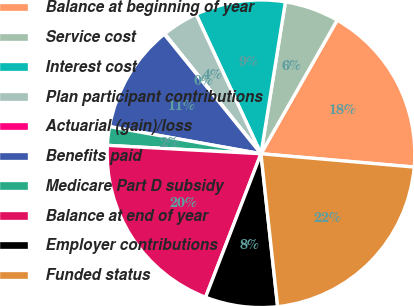<chart> <loc_0><loc_0><loc_500><loc_500><pie_chart><fcel>Balance at beginning of year<fcel>Service cost<fcel>Interest cost<fcel>Plan participant contributions<fcel>Actuarial (gain)/loss<fcel>Benefits paid<fcel>Medicare Part D subsidy<fcel>Balance at end of year<fcel>Employer contributions<fcel>Funded status<nl><fcel>18.13%<fcel>5.71%<fcel>9.47%<fcel>3.83%<fcel>0.07%<fcel>11.35%<fcel>1.95%<fcel>20.01%<fcel>7.59%<fcel>21.89%<nl></chart> 